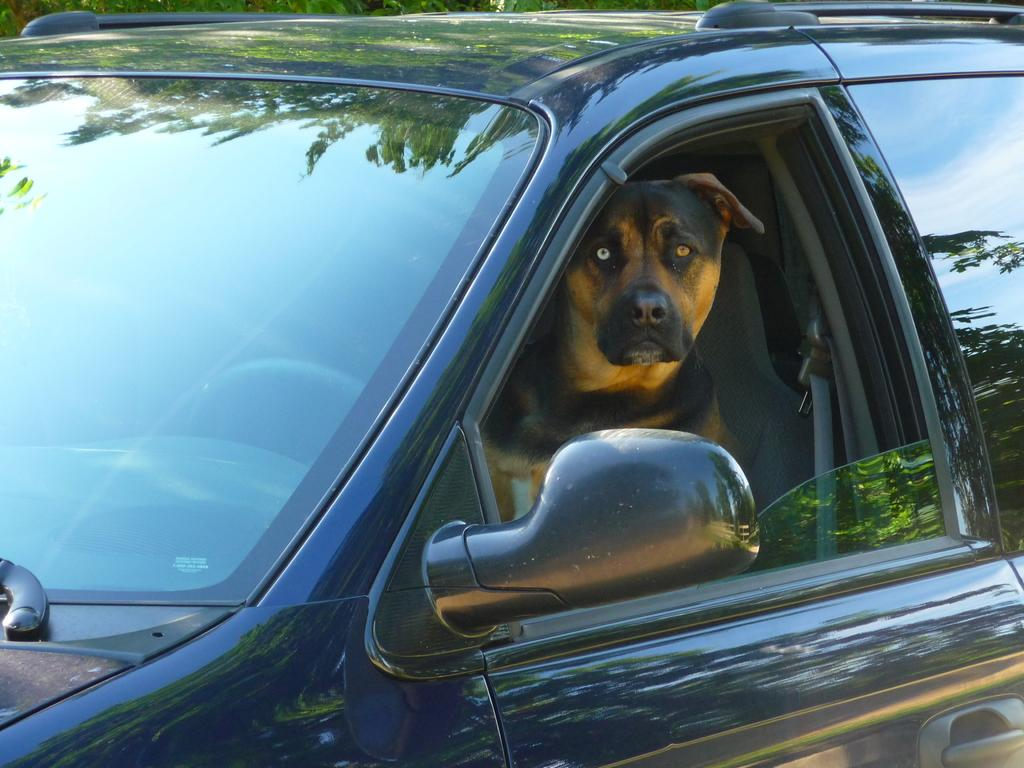What is the main subject of the image? The main subject of the image is a car. Is there anything inside the car? Yes, there is a dog inside the car. What type of cap is the dog wearing in the image? There is no cap present on the dog in the image. Where is the hall located in the image? There is no hall mentioned or visible in the image. 